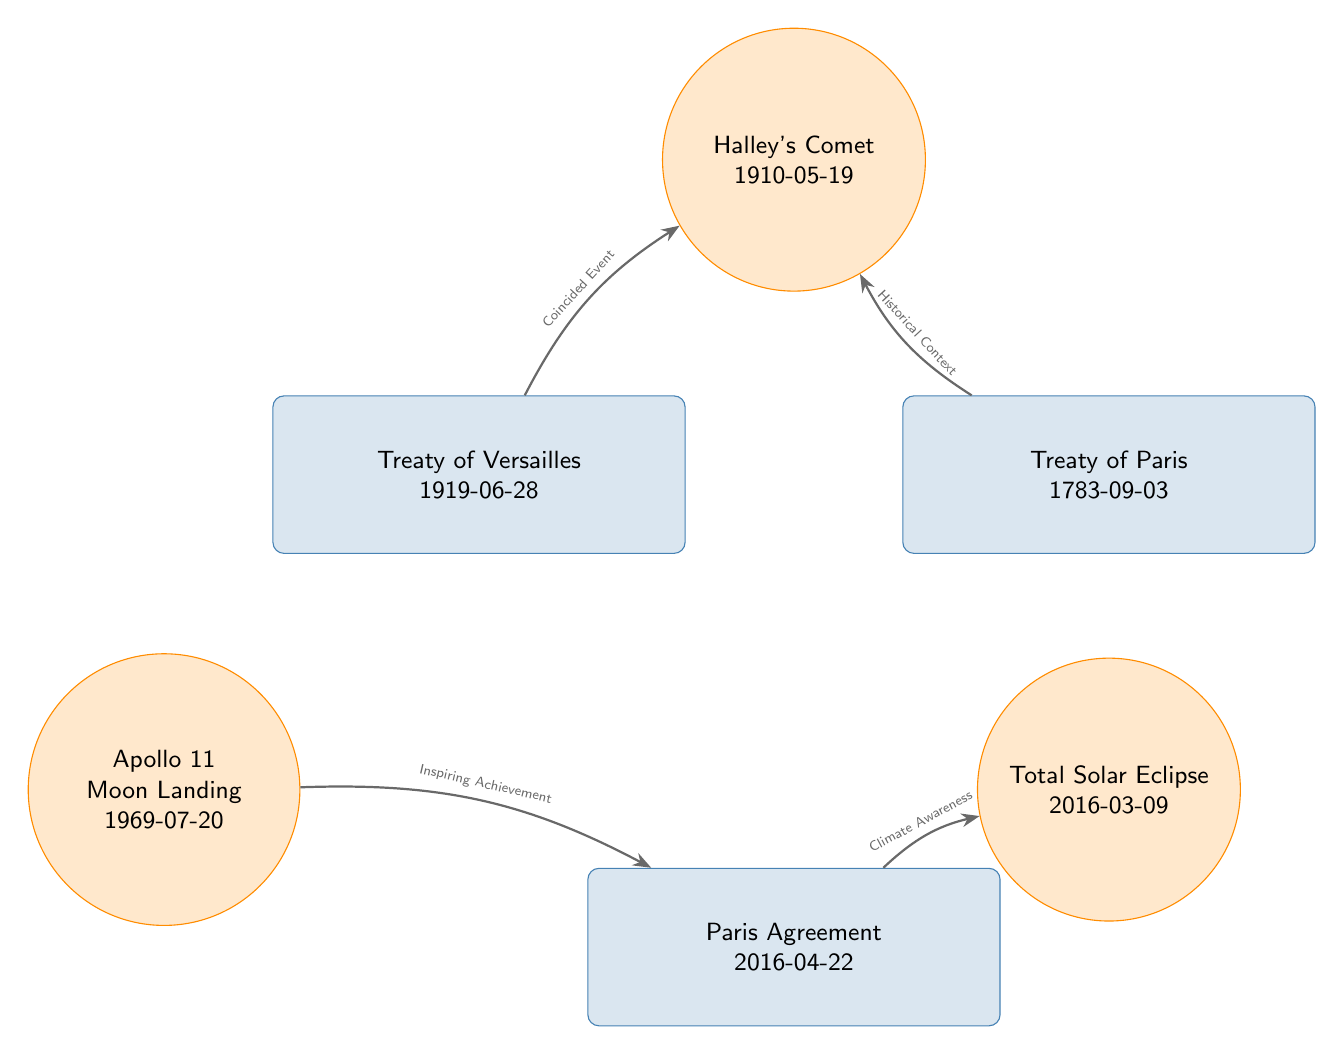What is the title of the treaty represented at the top left? The node located at the top left is labeled with the title "Treaty of Versailles", which is clearly indicated on the diagram.
Answer: Treaty of Versailles What is the date of the Apollo 11 Moon Landing event? The node labeled "Apollo 11 Moon Landing" has the date "1969-07-20" listed directly below it in the diagram.
Answer: 1969-07-20 How many treaties are represented in the diagram? By counting the number of nodes designated with the treaty style, there are three treaties: "Treaty of Versailles," "Treaty of Paris," and "Paris Agreement."
Answer: 3 What type of event is represented by the node on the bottom right? The node positioned at the bottom right is labeled as a "Total Solar Eclipse," categorizing it as an astronomical event.
Answer: Total Solar Eclipse Which treaty is associated with the "Inspiring Achievement" connection? The connection labeled "Inspiring Achievement" leads from the "Apollo 11 Moon Landing" event to the "Paris Agreement" treaty node.
Answer: Paris Agreement What is the historical context mentioned with Halley's Comet? The relationship from the "Treaty of Paris" to the "Halley's Comet" node is designated as "Historical Context," indicating the context of the treaty is referred to by this astronomical event.
Answer: Historical Context How many events are represented in the diagram? There are three event nodes indicated: "Apollo 11 Moon Landing," "Halley's Comet," and "Total Solar Eclipse," making the total of events three.
Answer: 3 Which astronomical event coincided with the Treaty of Versailles? The diagram shows a connection indicating that "Halley's Comet" coincided with the "Treaty of Versailles," as indicated by the label on the connection.
Answer: Halley's Comet What does the connection labeled "Climate Awareness" lead to? The connection titled "Climate Awareness" originates from the "Paris Agreement" treaty and points towards the "Total Solar Eclipse," showing this thematic connection.
Answer: Total Solar Eclipse 